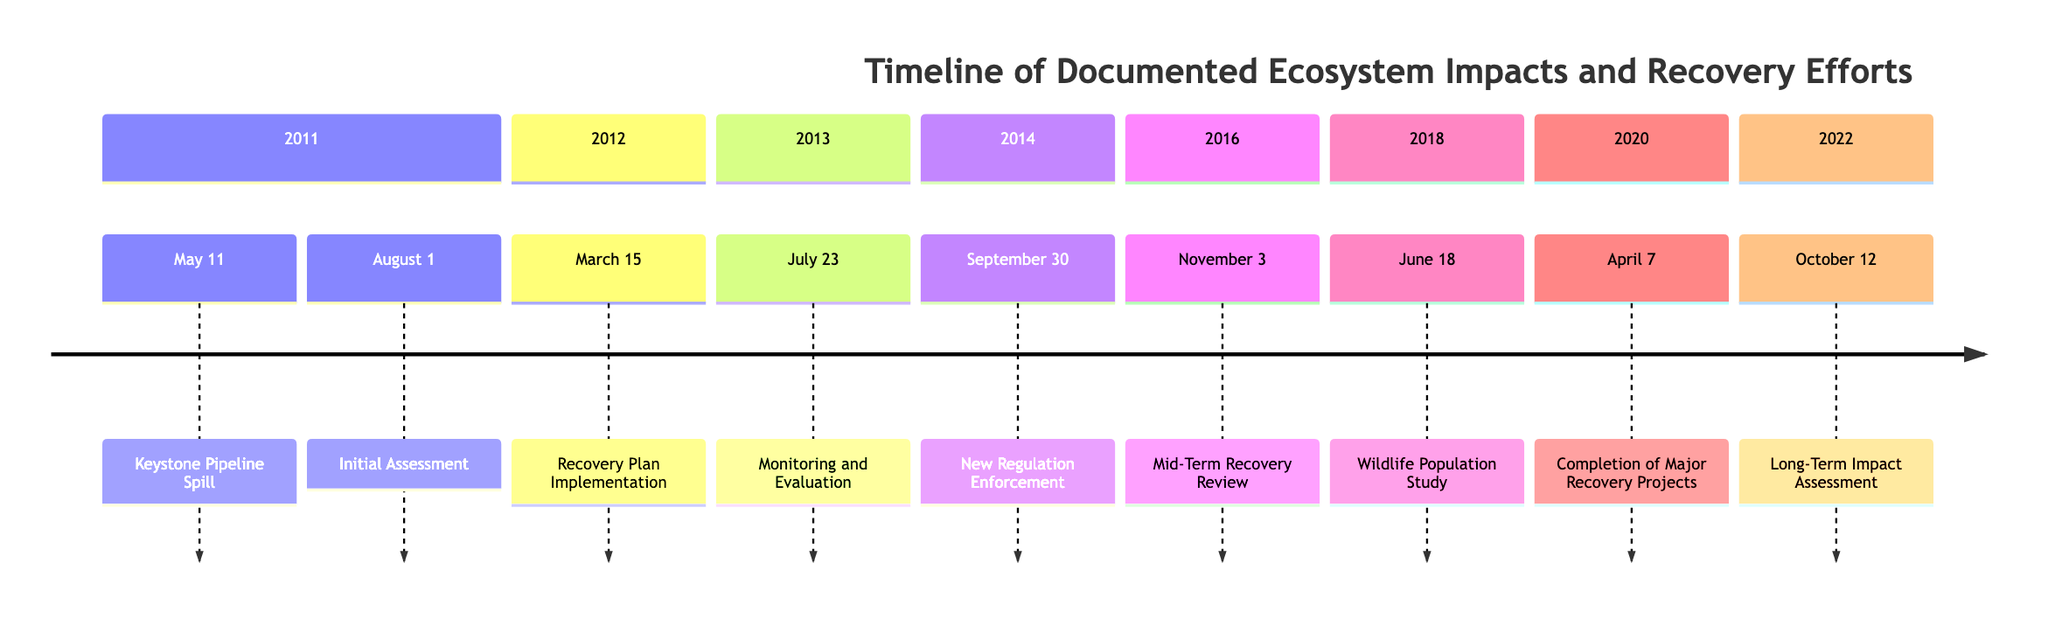What event occurred on May 11, 2011? The timeline indicates that the Keystone Pipeline Spill occurred on this date, which was a significant oil spill reported in North Dakota.
Answer: Keystone Pipeline Spill What organization began the initial assessment on August 1, 2011? The diagram shows that the Environmental Protection Agency (EPA) began this assessment on the specified date.
Answer: Environmental Protection Agency (EPA) How many total events are documented in the timeline? By counting the individual events listed in the timeline, we can see there are nine documented events.
Answer: 9 What was the primary focus of the recovery plan implemented on March 15, 2012? The recovery plan aimed at rehabilitating affected water sources and wildlife habitats as initiated by the EPA and local environmental groups.
Answer: Rehabilitation of water sources and habitats What year did the Long-Term Impact Assessment take place? The final long-term impact assessment is dated October 12, 2022, which is explicitly stated in the timeline.
Answer: 2022 Which event indicates the completion of major recovery projects and when did it occur? The timeline details that the completion of several major recovery projects occurred on April 7, 2020.
Answer: April 7, 2020 What does the Mid-Term Recovery Review in 2016 highlight about the ecosystem recovery? The review indicated significant improvements in water quality but mentioned ongoing challenges for wildlife, noted in the timeline.
Answer: Significant improvements in water quality What is the overall trend of wildlife populations according to the study in 2018? The study from June 18, 2018, found partial recovery in local fish and bird populations, indicating positive effects from recovery efforts.
Answer: Partial recovery What action was enforced on September 30, 2014, to prevent future incidents? The timeline states that new safety regulations were enforced for pipeline maintenance and crisis response to prevent future incidents.
Answer: New safety regulations 